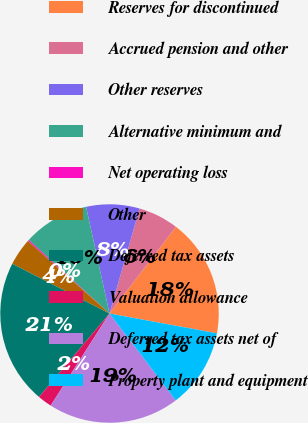<chart> <loc_0><loc_0><loc_500><loc_500><pie_chart><fcel>Reserves for discontinued<fcel>Accrued pension and other<fcel>Other reserves<fcel>Alternative minimum and<fcel>Net operating loss<fcel>Other<fcel>Deferred tax assets<fcel>Valuation allowance<fcel>Deferred tax assets net of<fcel>Property plant and equipment<nl><fcel>17.5%<fcel>5.96%<fcel>7.88%<fcel>9.81%<fcel>0.19%<fcel>4.04%<fcel>21.35%<fcel>2.12%<fcel>19.42%<fcel>11.73%<nl></chart> 